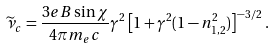<formula> <loc_0><loc_0><loc_500><loc_500>\widetilde { \nu } _ { c } = \frac { 3 e B \sin \chi } { 4 \pi m _ { e } c } \gamma ^ { 2 } \left [ 1 + \gamma ^ { 2 } ( 1 - n ^ { 2 } _ { 1 , 2 } ) \right ] ^ { - 3 / 2 } \, .</formula> 